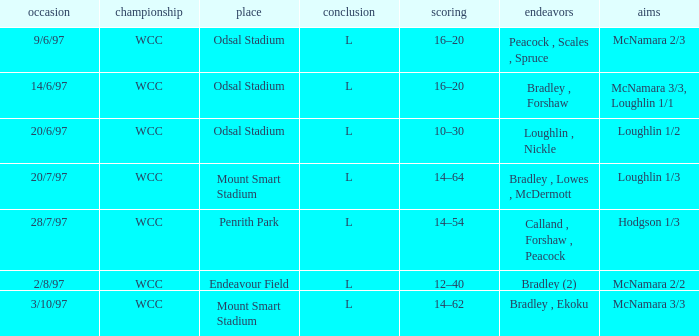What was the score on 20/6/97? 10–30. 